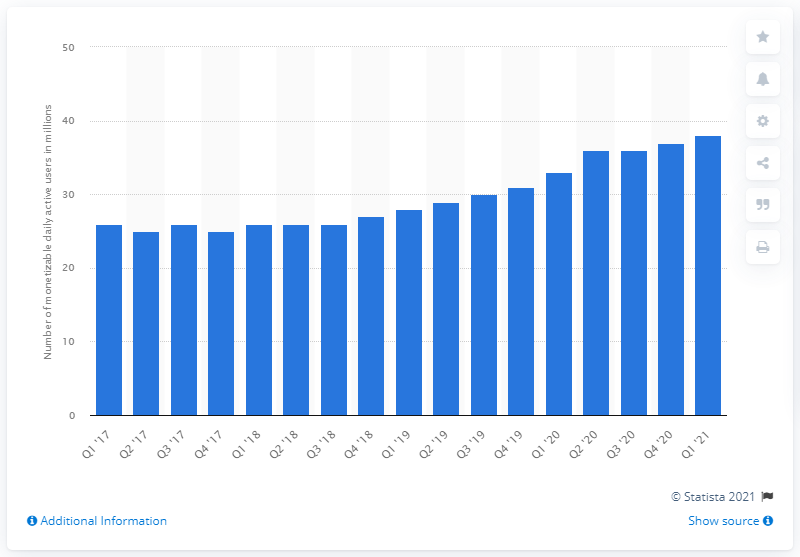Specify some key components in this picture. The number of monthly active users of mDAU in the U.S. in the last quarter of 2021 was 38. 